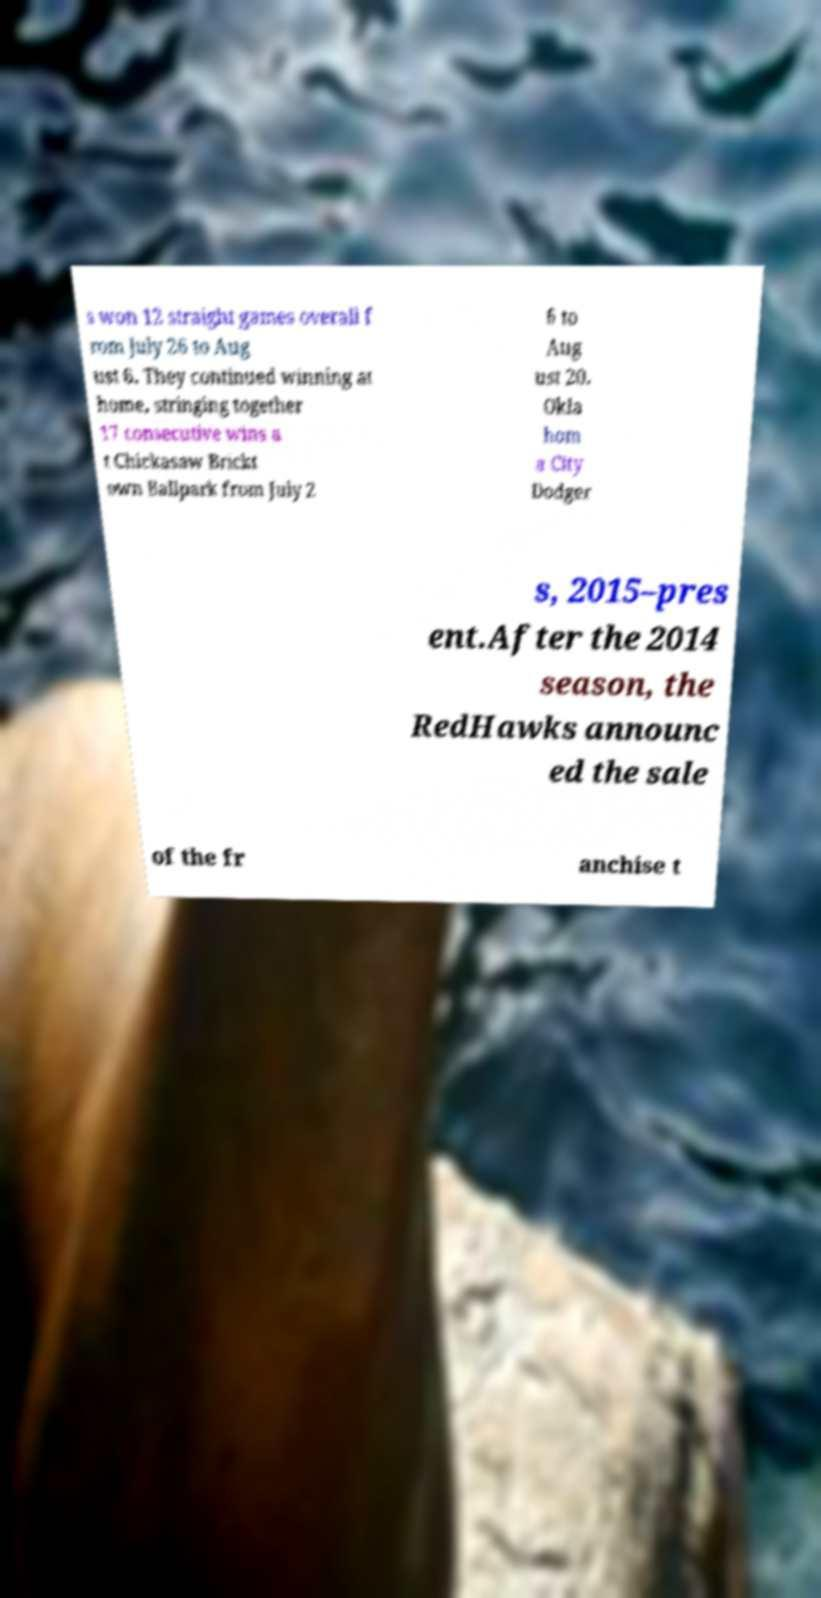Could you extract and type out the text from this image? s won 12 straight games overall f rom July 26 to Aug ust 6. They continued winning at home, stringing together 17 consecutive wins a t Chickasaw Brickt own Ballpark from July 2 6 to Aug ust 20. Okla hom a City Dodger s, 2015–pres ent.After the 2014 season, the RedHawks announc ed the sale of the fr anchise t 